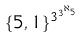<formula> <loc_0><loc_0><loc_500><loc_500>\{ 5 , 1 \} ^ { 3 ^ { 3 ^ { \aleph _ { 5 } } } }</formula> 